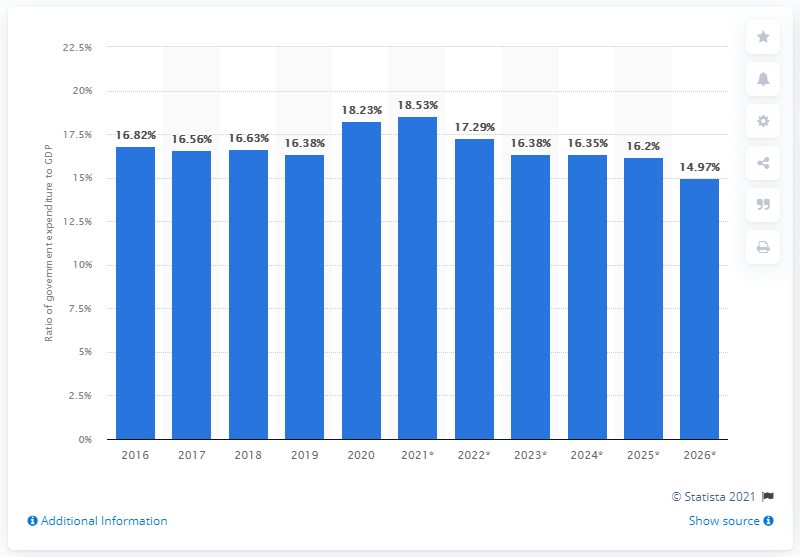Highlight a few significant elements in this photo. In 2020, government expenditure accounted for approximately 18.23% of Indonesia's GDP. 